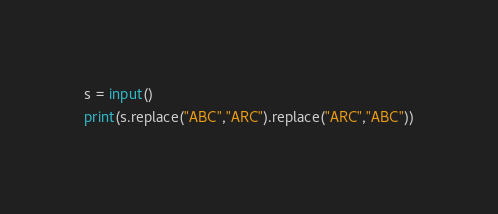<code> <loc_0><loc_0><loc_500><loc_500><_Python_>s = input()
print(s.replace("ABC","ARC").replace("ARC","ABC"))</code> 